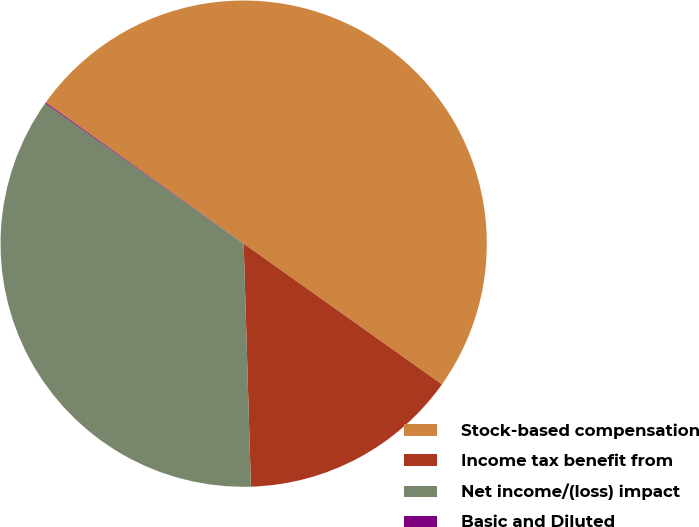Convert chart to OTSL. <chart><loc_0><loc_0><loc_500><loc_500><pie_chart><fcel>Stock-based compensation<fcel>Income tax benefit from<fcel>Net income/(loss) impact<fcel>Basic and Diluted<nl><fcel>49.96%<fcel>14.7%<fcel>35.26%<fcel>0.07%<nl></chart> 